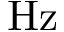<formula> <loc_0><loc_0><loc_500><loc_500>H z</formula> 